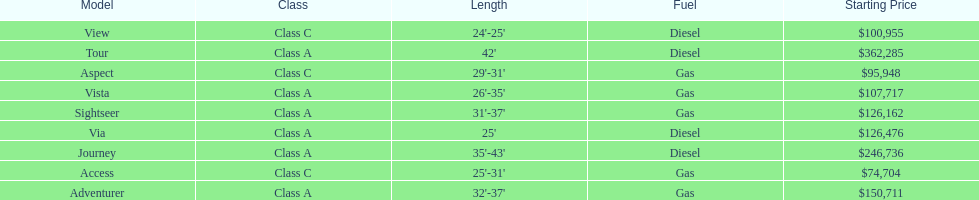Which model had the highest starting price Tour. 